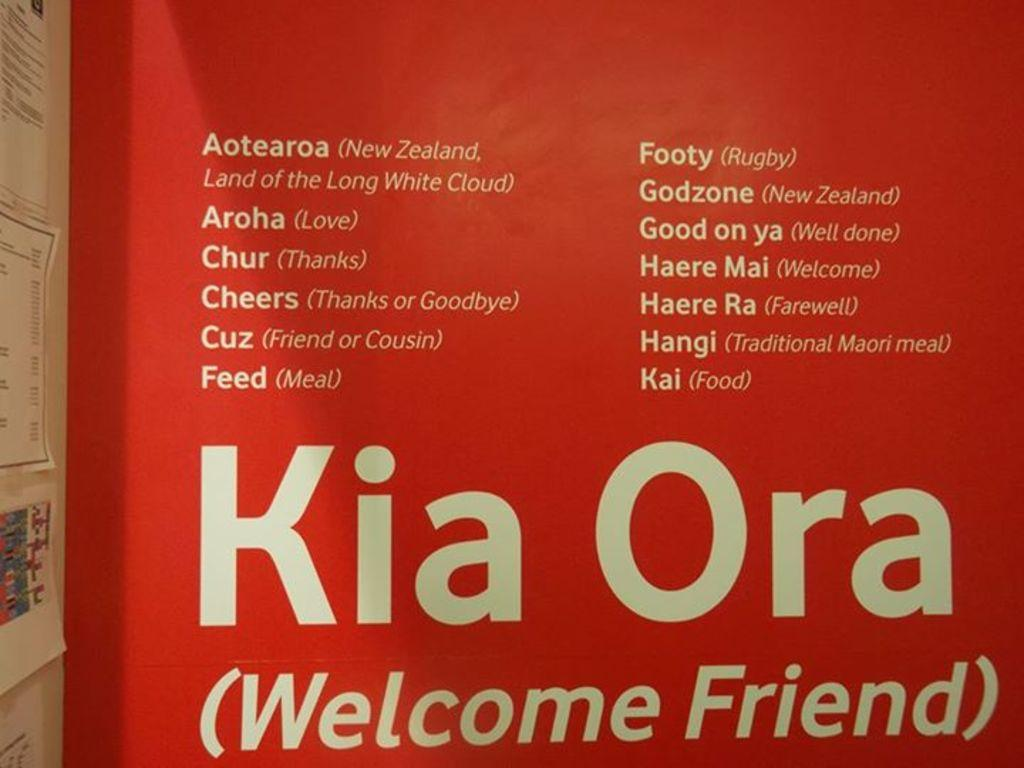<image>
Summarize the visual content of the image. A red sign with white writing that says Kia Ora. 